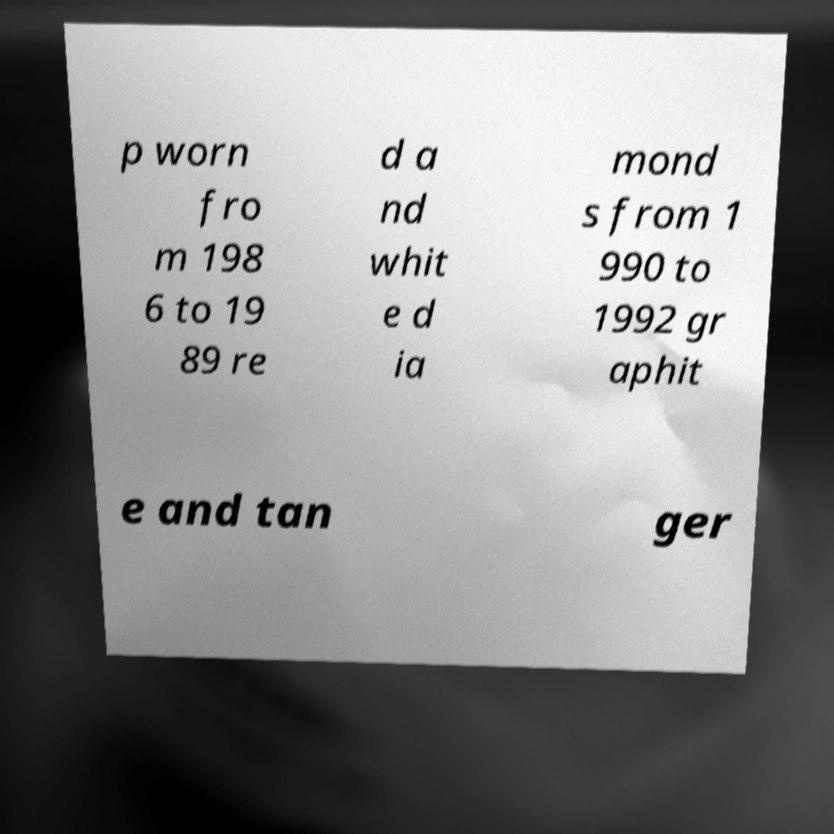Please read and relay the text visible in this image. What does it say? p worn fro m 198 6 to 19 89 re d a nd whit e d ia mond s from 1 990 to 1992 gr aphit e and tan ger 